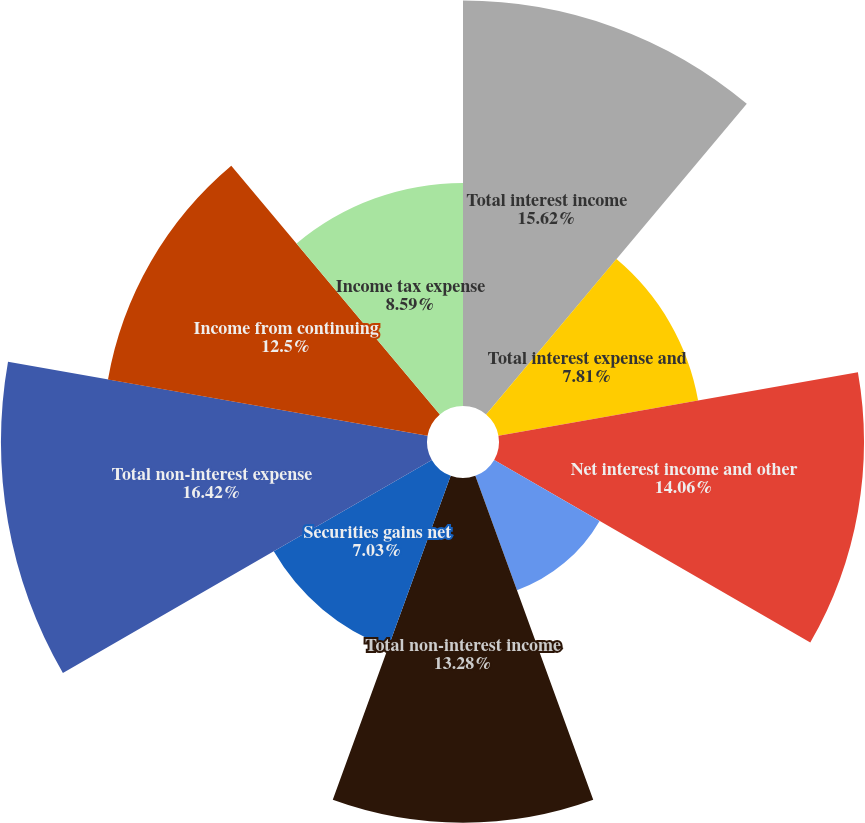Convert chart to OTSL. <chart><loc_0><loc_0><loc_500><loc_500><pie_chart><fcel>Total interest income<fcel>Total interest expense and<fcel>Net interest income and other<fcel>Provision for loan losses<fcel>Total non-interest income<fcel>Securities gains net<fcel>Total non-interest expense<fcel>Income from continuing<fcel>Income tax expense<nl><fcel>15.62%<fcel>7.81%<fcel>14.06%<fcel>4.69%<fcel>13.28%<fcel>7.03%<fcel>16.41%<fcel>12.5%<fcel>8.59%<nl></chart> 